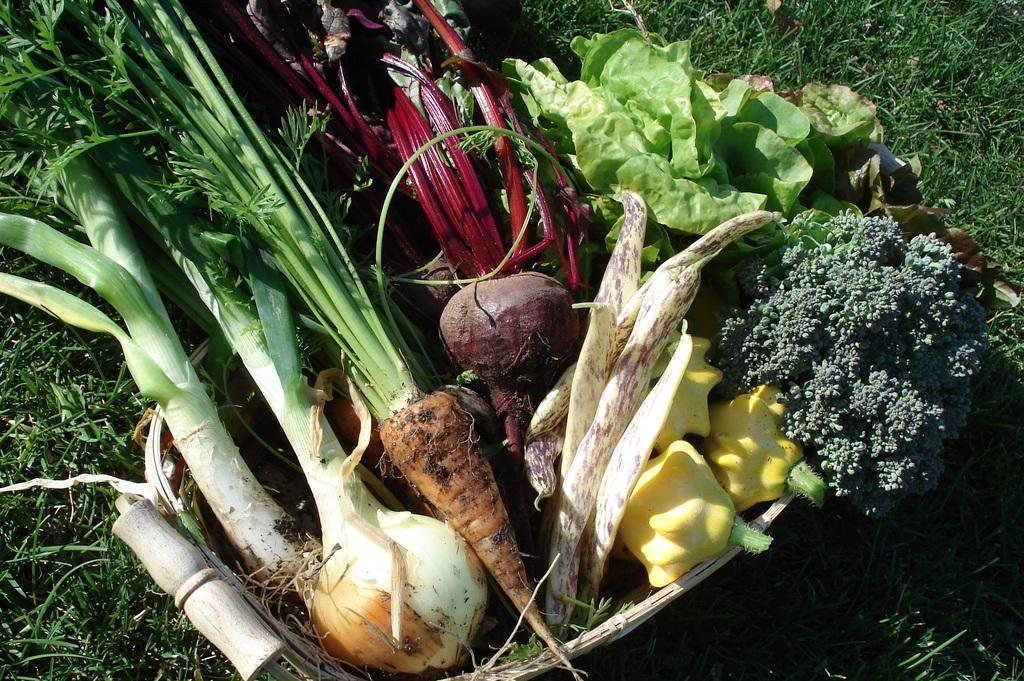Could you give a brief overview of what you see in this image? In this picture we can see vegetables on the grass such as carrots, beetroot and leaves. 